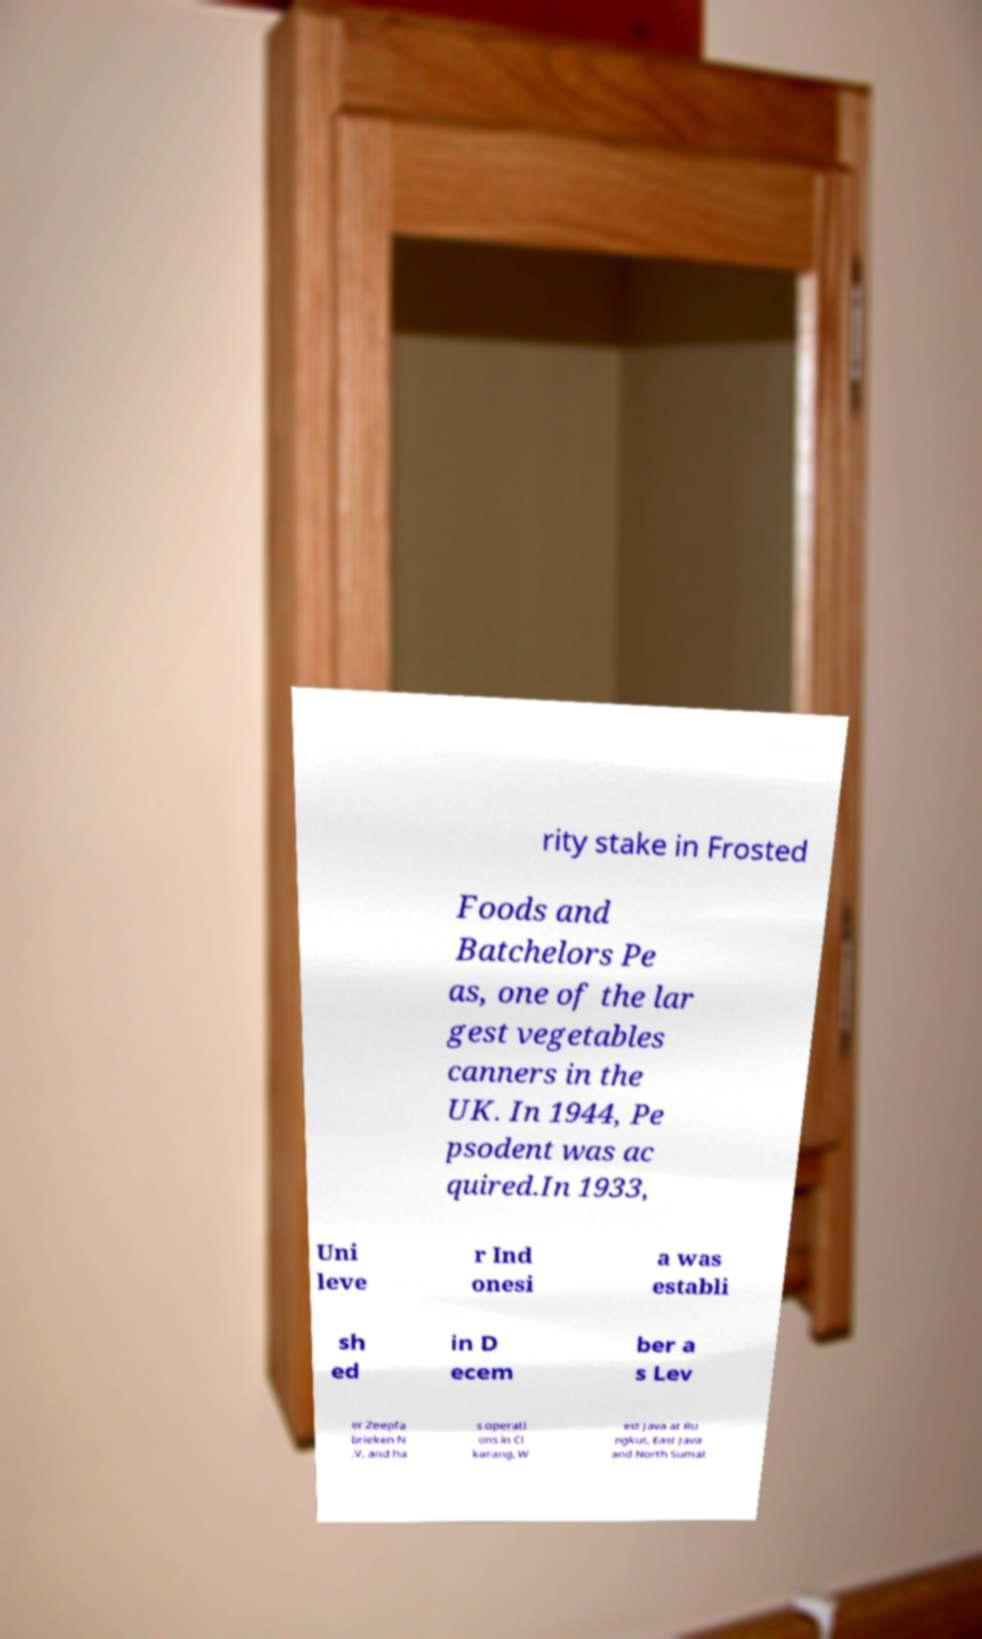I need the written content from this picture converted into text. Can you do that? rity stake in Frosted Foods and Batchelors Pe as, one of the lar gest vegetables canners in the UK. In 1944, Pe psodent was ac quired.In 1933, Uni leve r Ind onesi a was establi sh ed in D ecem ber a s Lev er Zeepfa brieken N .V. and ha s operati ons in Ci karang, W est Java at Ru ngkut, East Java and North Sumat 